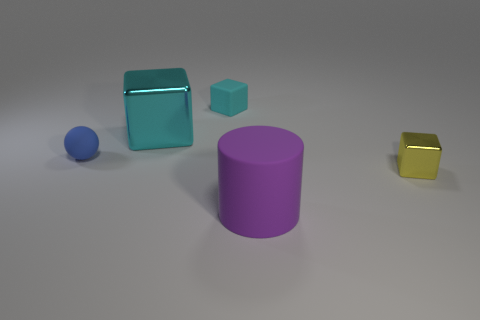How many objects are either tiny metal cylinders or rubber objects?
Your answer should be compact. 3. How many other things are the same material as the small yellow thing?
Your answer should be very brief. 1. Are there fewer large red metallic cubes than big things?
Give a very brief answer. Yes. Is the large object that is behind the large purple matte cylinder made of the same material as the large purple object?
Keep it short and to the point. No. What number of blocks are either small cyan things or big metallic objects?
Your answer should be compact. 2. What is the shape of the object that is to the left of the tiny rubber cube and behind the small blue thing?
Your answer should be compact. Cube. There is a small shiny block in front of the small rubber thing behind the matte thing to the left of the big cyan shiny thing; what color is it?
Your answer should be compact. Yellow. Are there fewer small cyan blocks behind the blue rubber ball than big green metallic blocks?
Your answer should be compact. No. Is the shape of the large thing in front of the tiny yellow cube the same as the small rubber thing that is in front of the large cyan shiny object?
Your answer should be very brief. No. How many objects are either tiny things that are to the left of the big cyan thing or small shiny blocks?
Make the answer very short. 2. 